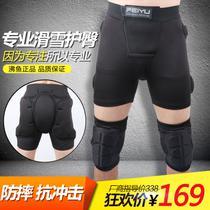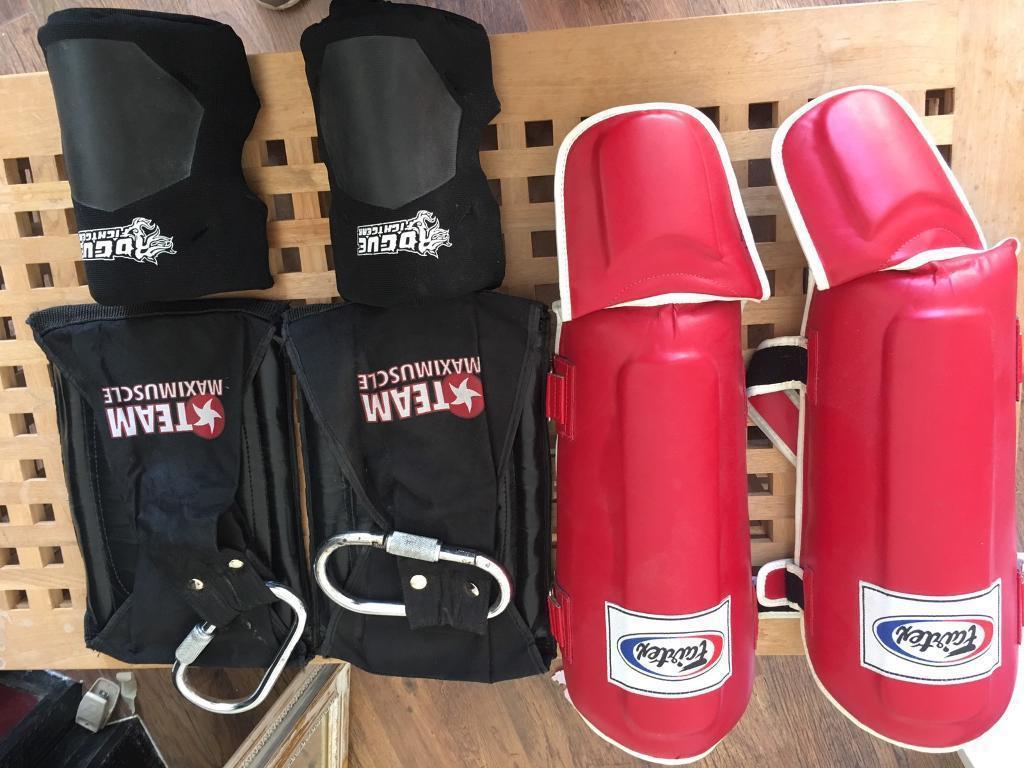The first image is the image on the left, the second image is the image on the right. Analyze the images presented: Is the assertion "All images show legs wearing kneepads." valid? Answer yes or no. No. The first image is the image on the left, the second image is the image on the right. Analyze the images presented: Is the assertion "An image shows legs only wearing non-bulky knee wraps, and shows three color options." valid? Answer yes or no. No. The first image is the image on the left, the second image is the image on the right. Evaluate the accuracy of this statement regarding the images: "One of the images appears to contain at least three female knees.". Is it true? Answer yes or no. No. The first image is the image on the left, the second image is the image on the right. Assess this claim about the two images: "At least one of the images does not contain the legs of a human.". Correct or not? Answer yes or no. Yes. 